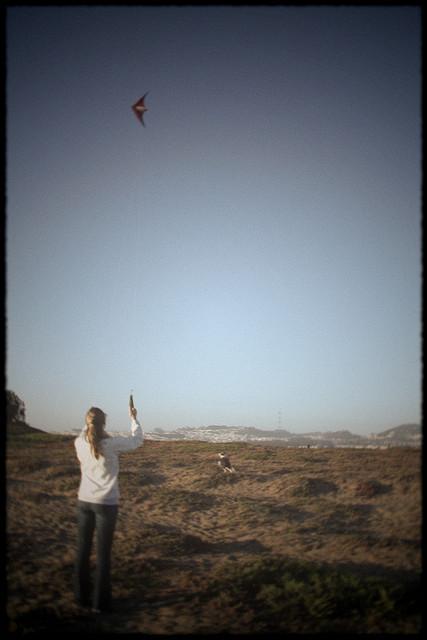How many people are wearing white shirts?
Give a very brief answer. 1. How many people are standing over the dog?
Give a very brief answer. 1. How many kites are flying in the sky?
Give a very brief answer. 1. How many beds are pictured?
Give a very brief answer. 0. How many people are there?
Give a very brief answer. 1. How many large elephants are standing?
Give a very brief answer. 0. 